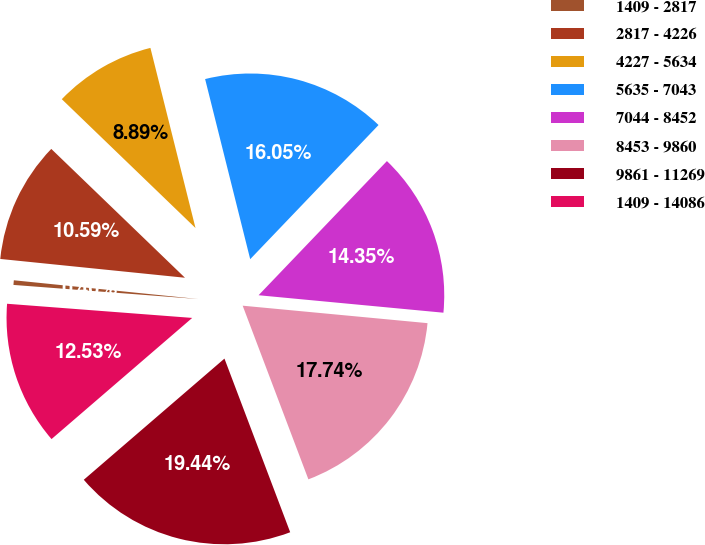Convert chart to OTSL. <chart><loc_0><loc_0><loc_500><loc_500><pie_chart><fcel>1409 - 2817<fcel>2817 - 4226<fcel>4227 - 5634<fcel>5635 - 7043<fcel>7044 - 8452<fcel>8453 - 9860<fcel>9861 - 11269<fcel>1409 - 14086<nl><fcel>0.4%<fcel>10.59%<fcel>8.89%<fcel>16.05%<fcel>14.35%<fcel>17.74%<fcel>19.44%<fcel>12.53%<nl></chart> 